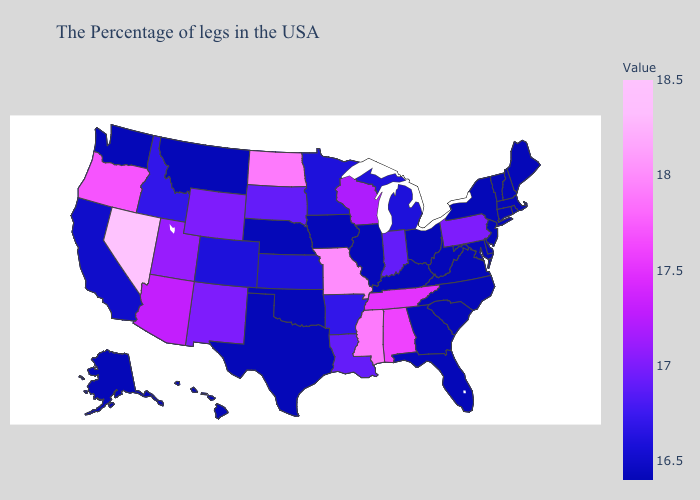Does Alaska have a higher value than Nevada?
Answer briefly. No. Does Nevada have the highest value in the USA?
Short answer required. Yes. Does the map have missing data?
Give a very brief answer. No. Among the states that border Maryland , which have the highest value?
Concise answer only. Pennsylvania. 